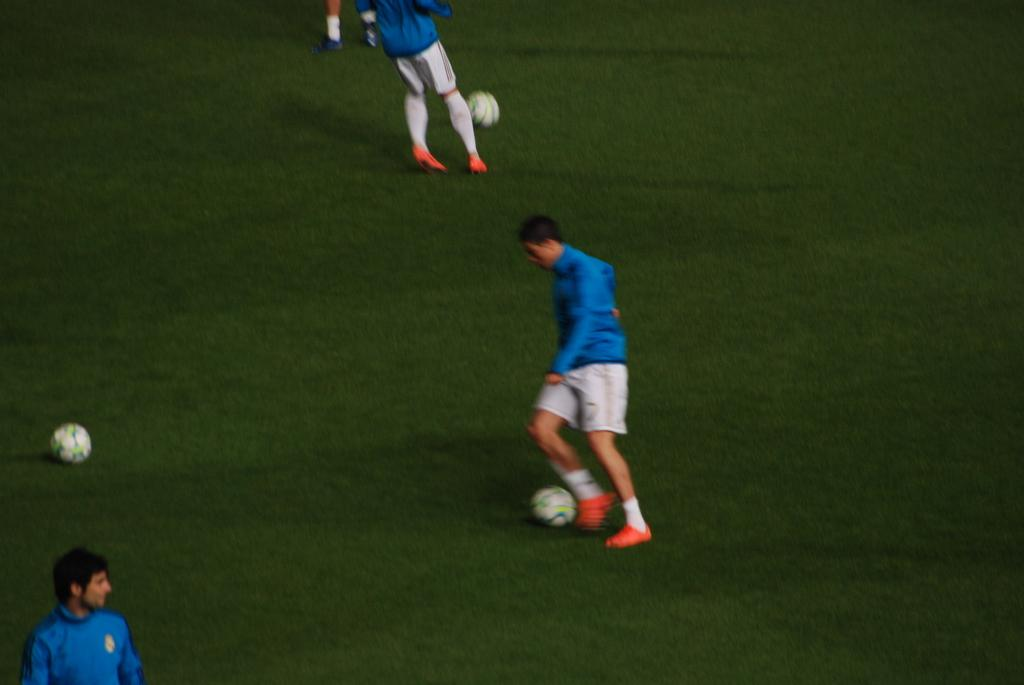Who is the main subject in the image? There is a boy in the image. What is the boy doing in the image? The boy is playing football. What color is the boy's shirt? The boy is wearing a blue shirt. What color are the boy's shorts? The boy is wearing white shorts. What else can be seen related to football in the image? There is another football in the left side of the image. What is the ground covered with? The ground is covered with green grass. Can you see any snails crawling on the football in the image? There are no snails visible in the image, and they are not related to the scene of the boy playing football. 